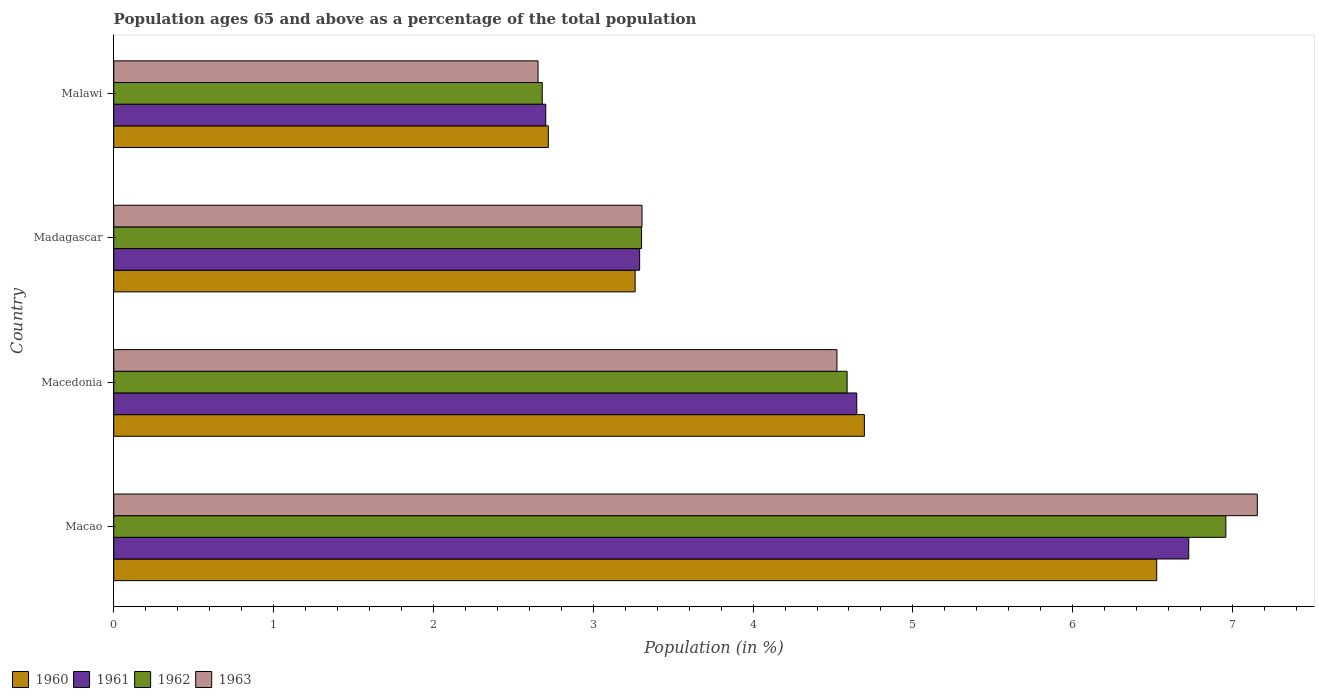How many different coloured bars are there?
Give a very brief answer. 4. How many groups of bars are there?
Your answer should be compact. 4. Are the number of bars on each tick of the Y-axis equal?
Keep it short and to the point. Yes. How many bars are there on the 2nd tick from the bottom?
Ensure brevity in your answer.  4. What is the label of the 2nd group of bars from the top?
Provide a succinct answer. Madagascar. What is the percentage of the population ages 65 and above in 1961 in Madagascar?
Make the answer very short. 3.29. Across all countries, what is the maximum percentage of the population ages 65 and above in 1963?
Provide a succinct answer. 7.15. Across all countries, what is the minimum percentage of the population ages 65 and above in 1963?
Provide a succinct answer. 2.65. In which country was the percentage of the population ages 65 and above in 1962 maximum?
Your response must be concise. Macao. In which country was the percentage of the population ages 65 and above in 1960 minimum?
Keep it short and to the point. Malawi. What is the total percentage of the population ages 65 and above in 1963 in the graph?
Your answer should be very brief. 17.64. What is the difference between the percentage of the population ages 65 and above in 1961 in Macao and that in Madagascar?
Keep it short and to the point. 3.44. What is the difference between the percentage of the population ages 65 and above in 1961 in Malawi and the percentage of the population ages 65 and above in 1960 in Madagascar?
Your response must be concise. -0.56. What is the average percentage of the population ages 65 and above in 1961 per country?
Offer a very short reply. 4.34. What is the difference between the percentage of the population ages 65 and above in 1960 and percentage of the population ages 65 and above in 1963 in Macao?
Provide a short and direct response. -0.63. What is the ratio of the percentage of the population ages 65 and above in 1962 in Madagascar to that in Malawi?
Make the answer very short. 1.23. What is the difference between the highest and the second highest percentage of the population ages 65 and above in 1961?
Give a very brief answer. 2.08. What is the difference between the highest and the lowest percentage of the population ages 65 and above in 1961?
Your answer should be compact. 4.02. Is the sum of the percentage of the population ages 65 and above in 1962 in Macedonia and Malawi greater than the maximum percentage of the population ages 65 and above in 1963 across all countries?
Your answer should be very brief. Yes. Is it the case that in every country, the sum of the percentage of the population ages 65 and above in 1961 and percentage of the population ages 65 and above in 1962 is greater than the sum of percentage of the population ages 65 and above in 1960 and percentage of the population ages 65 and above in 1963?
Provide a short and direct response. No. What does the 1st bar from the top in Macao represents?
Your response must be concise. 1963. Are all the bars in the graph horizontal?
Your answer should be compact. Yes. How many countries are there in the graph?
Give a very brief answer. 4. What is the difference between two consecutive major ticks on the X-axis?
Keep it short and to the point. 1. Are the values on the major ticks of X-axis written in scientific E-notation?
Your answer should be compact. No. Does the graph contain any zero values?
Offer a terse response. No. How many legend labels are there?
Make the answer very short. 4. How are the legend labels stacked?
Provide a succinct answer. Horizontal. What is the title of the graph?
Your answer should be very brief. Population ages 65 and above as a percentage of the total population. What is the label or title of the X-axis?
Give a very brief answer. Population (in %). What is the Population (in %) of 1960 in Macao?
Offer a very short reply. 6.53. What is the Population (in %) in 1961 in Macao?
Your answer should be very brief. 6.73. What is the Population (in %) in 1962 in Macao?
Your answer should be compact. 6.96. What is the Population (in %) of 1963 in Macao?
Your answer should be compact. 7.15. What is the Population (in %) of 1960 in Macedonia?
Your answer should be very brief. 4.7. What is the Population (in %) of 1961 in Macedonia?
Provide a succinct answer. 4.65. What is the Population (in %) in 1962 in Macedonia?
Offer a terse response. 4.59. What is the Population (in %) in 1963 in Macedonia?
Your response must be concise. 4.52. What is the Population (in %) in 1960 in Madagascar?
Provide a succinct answer. 3.26. What is the Population (in %) in 1961 in Madagascar?
Keep it short and to the point. 3.29. What is the Population (in %) in 1962 in Madagascar?
Your answer should be very brief. 3.3. What is the Population (in %) of 1963 in Madagascar?
Provide a short and direct response. 3.31. What is the Population (in %) of 1960 in Malawi?
Keep it short and to the point. 2.72. What is the Population (in %) in 1961 in Malawi?
Offer a terse response. 2.7. What is the Population (in %) in 1962 in Malawi?
Make the answer very short. 2.68. What is the Population (in %) of 1963 in Malawi?
Provide a short and direct response. 2.65. Across all countries, what is the maximum Population (in %) of 1960?
Provide a succinct answer. 6.53. Across all countries, what is the maximum Population (in %) of 1961?
Your answer should be very brief. 6.73. Across all countries, what is the maximum Population (in %) in 1962?
Your answer should be very brief. 6.96. Across all countries, what is the maximum Population (in %) in 1963?
Your response must be concise. 7.15. Across all countries, what is the minimum Population (in %) of 1960?
Give a very brief answer. 2.72. Across all countries, what is the minimum Population (in %) of 1961?
Provide a succinct answer. 2.7. Across all countries, what is the minimum Population (in %) of 1962?
Offer a terse response. 2.68. Across all countries, what is the minimum Population (in %) of 1963?
Offer a very short reply. 2.65. What is the total Population (in %) in 1960 in the graph?
Your response must be concise. 17.2. What is the total Population (in %) in 1961 in the graph?
Keep it short and to the point. 17.37. What is the total Population (in %) of 1962 in the graph?
Offer a terse response. 17.53. What is the total Population (in %) of 1963 in the graph?
Your response must be concise. 17.64. What is the difference between the Population (in %) of 1960 in Macao and that in Macedonia?
Your response must be concise. 1.83. What is the difference between the Population (in %) in 1961 in Macao and that in Macedonia?
Give a very brief answer. 2.08. What is the difference between the Population (in %) of 1962 in Macao and that in Macedonia?
Ensure brevity in your answer.  2.37. What is the difference between the Population (in %) in 1963 in Macao and that in Macedonia?
Your response must be concise. 2.63. What is the difference between the Population (in %) in 1960 in Macao and that in Madagascar?
Provide a succinct answer. 3.26. What is the difference between the Population (in %) of 1961 in Macao and that in Madagascar?
Offer a very short reply. 3.44. What is the difference between the Population (in %) in 1962 in Macao and that in Madagascar?
Offer a terse response. 3.66. What is the difference between the Population (in %) in 1963 in Macao and that in Madagascar?
Offer a very short reply. 3.85. What is the difference between the Population (in %) of 1960 in Macao and that in Malawi?
Your answer should be very brief. 3.81. What is the difference between the Population (in %) of 1961 in Macao and that in Malawi?
Your response must be concise. 4.02. What is the difference between the Population (in %) of 1962 in Macao and that in Malawi?
Offer a terse response. 4.28. What is the difference between the Population (in %) in 1963 in Macao and that in Malawi?
Offer a terse response. 4.5. What is the difference between the Population (in %) of 1960 in Macedonia and that in Madagascar?
Keep it short and to the point. 1.43. What is the difference between the Population (in %) in 1961 in Macedonia and that in Madagascar?
Offer a terse response. 1.36. What is the difference between the Population (in %) in 1962 in Macedonia and that in Madagascar?
Your answer should be very brief. 1.29. What is the difference between the Population (in %) in 1963 in Macedonia and that in Madagascar?
Ensure brevity in your answer.  1.22. What is the difference between the Population (in %) in 1960 in Macedonia and that in Malawi?
Make the answer very short. 1.98. What is the difference between the Population (in %) of 1961 in Macedonia and that in Malawi?
Your answer should be compact. 1.95. What is the difference between the Population (in %) in 1962 in Macedonia and that in Malawi?
Give a very brief answer. 1.91. What is the difference between the Population (in %) of 1963 in Macedonia and that in Malawi?
Your answer should be very brief. 1.87. What is the difference between the Population (in %) in 1960 in Madagascar and that in Malawi?
Make the answer very short. 0.54. What is the difference between the Population (in %) of 1961 in Madagascar and that in Malawi?
Keep it short and to the point. 0.59. What is the difference between the Population (in %) of 1962 in Madagascar and that in Malawi?
Keep it short and to the point. 0.62. What is the difference between the Population (in %) of 1963 in Madagascar and that in Malawi?
Keep it short and to the point. 0.65. What is the difference between the Population (in %) of 1960 in Macao and the Population (in %) of 1961 in Macedonia?
Offer a very short reply. 1.88. What is the difference between the Population (in %) in 1960 in Macao and the Population (in %) in 1962 in Macedonia?
Offer a very short reply. 1.94. What is the difference between the Population (in %) of 1960 in Macao and the Population (in %) of 1963 in Macedonia?
Keep it short and to the point. 2. What is the difference between the Population (in %) of 1961 in Macao and the Population (in %) of 1962 in Macedonia?
Your response must be concise. 2.14. What is the difference between the Population (in %) of 1961 in Macao and the Population (in %) of 1963 in Macedonia?
Offer a very short reply. 2.2. What is the difference between the Population (in %) in 1962 in Macao and the Population (in %) in 1963 in Macedonia?
Ensure brevity in your answer.  2.43. What is the difference between the Population (in %) in 1960 in Macao and the Population (in %) in 1961 in Madagascar?
Your answer should be very brief. 3.23. What is the difference between the Population (in %) of 1960 in Macao and the Population (in %) of 1962 in Madagascar?
Give a very brief answer. 3.22. What is the difference between the Population (in %) of 1960 in Macao and the Population (in %) of 1963 in Madagascar?
Your answer should be compact. 3.22. What is the difference between the Population (in %) of 1961 in Macao and the Population (in %) of 1962 in Madagascar?
Offer a very short reply. 3.42. What is the difference between the Population (in %) of 1961 in Macao and the Population (in %) of 1963 in Madagascar?
Your answer should be compact. 3.42. What is the difference between the Population (in %) of 1962 in Macao and the Population (in %) of 1963 in Madagascar?
Keep it short and to the point. 3.65. What is the difference between the Population (in %) of 1960 in Macao and the Population (in %) of 1961 in Malawi?
Offer a very short reply. 3.82. What is the difference between the Population (in %) in 1960 in Macao and the Population (in %) in 1962 in Malawi?
Keep it short and to the point. 3.84. What is the difference between the Population (in %) in 1960 in Macao and the Population (in %) in 1963 in Malawi?
Make the answer very short. 3.87. What is the difference between the Population (in %) of 1961 in Macao and the Population (in %) of 1962 in Malawi?
Provide a succinct answer. 4.04. What is the difference between the Population (in %) of 1961 in Macao and the Population (in %) of 1963 in Malawi?
Offer a very short reply. 4.07. What is the difference between the Population (in %) in 1962 in Macao and the Population (in %) in 1963 in Malawi?
Your answer should be compact. 4.3. What is the difference between the Population (in %) of 1960 in Macedonia and the Population (in %) of 1961 in Madagascar?
Provide a short and direct response. 1.41. What is the difference between the Population (in %) of 1960 in Macedonia and the Population (in %) of 1962 in Madagascar?
Offer a very short reply. 1.39. What is the difference between the Population (in %) in 1960 in Macedonia and the Population (in %) in 1963 in Madagascar?
Give a very brief answer. 1.39. What is the difference between the Population (in %) in 1961 in Macedonia and the Population (in %) in 1962 in Madagascar?
Offer a terse response. 1.35. What is the difference between the Population (in %) of 1961 in Macedonia and the Population (in %) of 1963 in Madagascar?
Ensure brevity in your answer.  1.34. What is the difference between the Population (in %) in 1962 in Macedonia and the Population (in %) in 1963 in Madagascar?
Give a very brief answer. 1.28. What is the difference between the Population (in %) of 1960 in Macedonia and the Population (in %) of 1961 in Malawi?
Ensure brevity in your answer.  1.99. What is the difference between the Population (in %) of 1960 in Macedonia and the Population (in %) of 1962 in Malawi?
Keep it short and to the point. 2.02. What is the difference between the Population (in %) of 1960 in Macedonia and the Population (in %) of 1963 in Malawi?
Your response must be concise. 2.04. What is the difference between the Population (in %) of 1961 in Macedonia and the Population (in %) of 1962 in Malawi?
Offer a terse response. 1.97. What is the difference between the Population (in %) in 1961 in Macedonia and the Population (in %) in 1963 in Malawi?
Your answer should be very brief. 1.99. What is the difference between the Population (in %) in 1962 in Macedonia and the Population (in %) in 1963 in Malawi?
Your response must be concise. 1.93. What is the difference between the Population (in %) of 1960 in Madagascar and the Population (in %) of 1961 in Malawi?
Offer a very short reply. 0.56. What is the difference between the Population (in %) in 1960 in Madagascar and the Population (in %) in 1962 in Malawi?
Give a very brief answer. 0.58. What is the difference between the Population (in %) in 1960 in Madagascar and the Population (in %) in 1963 in Malawi?
Offer a terse response. 0.61. What is the difference between the Population (in %) of 1961 in Madagascar and the Population (in %) of 1962 in Malawi?
Provide a succinct answer. 0.61. What is the difference between the Population (in %) of 1961 in Madagascar and the Population (in %) of 1963 in Malawi?
Keep it short and to the point. 0.64. What is the difference between the Population (in %) of 1962 in Madagascar and the Population (in %) of 1963 in Malawi?
Keep it short and to the point. 0.65. What is the average Population (in %) of 1960 per country?
Provide a succinct answer. 4.3. What is the average Population (in %) of 1961 per country?
Offer a very short reply. 4.34. What is the average Population (in %) of 1962 per country?
Ensure brevity in your answer.  4.38. What is the average Population (in %) of 1963 per country?
Provide a succinct answer. 4.41. What is the difference between the Population (in %) in 1960 and Population (in %) in 1961 in Macao?
Your answer should be compact. -0.2. What is the difference between the Population (in %) of 1960 and Population (in %) of 1962 in Macao?
Ensure brevity in your answer.  -0.43. What is the difference between the Population (in %) of 1960 and Population (in %) of 1963 in Macao?
Keep it short and to the point. -0.63. What is the difference between the Population (in %) of 1961 and Population (in %) of 1962 in Macao?
Your answer should be very brief. -0.23. What is the difference between the Population (in %) in 1961 and Population (in %) in 1963 in Macao?
Provide a succinct answer. -0.43. What is the difference between the Population (in %) in 1962 and Population (in %) in 1963 in Macao?
Ensure brevity in your answer.  -0.2. What is the difference between the Population (in %) of 1960 and Population (in %) of 1961 in Macedonia?
Keep it short and to the point. 0.05. What is the difference between the Population (in %) in 1960 and Population (in %) in 1962 in Macedonia?
Keep it short and to the point. 0.11. What is the difference between the Population (in %) of 1960 and Population (in %) of 1963 in Macedonia?
Make the answer very short. 0.17. What is the difference between the Population (in %) in 1961 and Population (in %) in 1962 in Macedonia?
Ensure brevity in your answer.  0.06. What is the difference between the Population (in %) of 1961 and Population (in %) of 1963 in Macedonia?
Ensure brevity in your answer.  0.12. What is the difference between the Population (in %) in 1962 and Population (in %) in 1963 in Macedonia?
Offer a very short reply. 0.06. What is the difference between the Population (in %) of 1960 and Population (in %) of 1961 in Madagascar?
Your answer should be compact. -0.03. What is the difference between the Population (in %) of 1960 and Population (in %) of 1962 in Madagascar?
Provide a succinct answer. -0.04. What is the difference between the Population (in %) in 1960 and Population (in %) in 1963 in Madagascar?
Your answer should be compact. -0.04. What is the difference between the Population (in %) in 1961 and Population (in %) in 1962 in Madagascar?
Offer a terse response. -0.01. What is the difference between the Population (in %) in 1961 and Population (in %) in 1963 in Madagascar?
Provide a short and direct response. -0.01. What is the difference between the Population (in %) in 1962 and Population (in %) in 1963 in Madagascar?
Make the answer very short. -0. What is the difference between the Population (in %) of 1960 and Population (in %) of 1961 in Malawi?
Ensure brevity in your answer.  0.02. What is the difference between the Population (in %) in 1960 and Population (in %) in 1962 in Malawi?
Give a very brief answer. 0.04. What is the difference between the Population (in %) in 1960 and Population (in %) in 1963 in Malawi?
Provide a short and direct response. 0.06. What is the difference between the Population (in %) in 1961 and Population (in %) in 1962 in Malawi?
Offer a terse response. 0.02. What is the difference between the Population (in %) of 1961 and Population (in %) of 1963 in Malawi?
Keep it short and to the point. 0.05. What is the difference between the Population (in %) in 1962 and Population (in %) in 1963 in Malawi?
Provide a succinct answer. 0.03. What is the ratio of the Population (in %) of 1960 in Macao to that in Macedonia?
Keep it short and to the point. 1.39. What is the ratio of the Population (in %) of 1961 in Macao to that in Macedonia?
Keep it short and to the point. 1.45. What is the ratio of the Population (in %) in 1962 in Macao to that in Macedonia?
Offer a terse response. 1.52. What is the ratio of the Population (in %) in 1963 in Macao to that in Macedonia?
Keep it short and to the point. 1.58. What is the ratio of the Population (in %) of 1960 in Macao to that in Madagascar?
Offer a terse response. 2. What is the ratio of the Population (in %) of 1961 in Macao to that in Madagascar?
Your response must be concise. 2.04. What is the ratio of the Population (in %) in 1962 in Macao to that in Madagascar?
Ensure brevity in your answer.  2.11. What is the ratio of the Population (in %) of 1963 in Macao to that in Madagascar?
Offer a terse response. 2.16. What is the ratio of the Population (in %) in 1960 in Macao to that in Malawi?
Provide a succinct answer. 2.4. What is the ratio of the Population (in %) of 1961 in Macao to that in Malawi?
Make the answer very short. 2.49. What is the ratio of the Population (in %) in 1962 in Macao to that in Malawi?
Provide a succinct answer. 2.6. What is the ratio of the Population (in %) of 1963 in Macao to that in Malawi?
Make the answer very short. 2.7. What is the ratio of the Population (in %) of 1960 in Macedonia to that in Madagascar?
Your response must be concise. 1.44. What is the ratio of the Population (in %) of 1961 in Macedonia to that in Madagascar?
Offer a terse response. 1.41. What is the ratio of the Population (in %) of 1962 in Macedonia to that in Madagascar?
Make the answer very short. 1.39. What is the ratio of the Population (in %) in 1963 in Macedonia to that in Madagascar?
Your answer should be compact. 1.37. What is the ratio of the Population (in %) of 1960 in Macedonia to that in Malawi?
Your answer should be very brief. 1.73. What is the ratio of the Population (in %) in 1961 in Macedonia to that in Malawi?
Provide a succinct answer. 1.72. What is the ratio of the Population (in %) of 1962 in Macedonia to that in Malawi?
Keep it short and to the point. 1.71. What is the ratio of the Population (in %) of 1963 in Macedonia to that in Malawi?
Make the answer very short. 1.7. What is the ratio of the Population (in %) in 1960 in Madagascar to that in Malawi?
Your answer should be compact. 1.2. What is the ratio of the Population (in %) of 1961 in Madagascar to that in Malawi?
Ensure brevity in your answer.  1.22. What is the ratio of the Population (in %) of 1962 in Madagascar to that in Malawi?
Provide a short and direct response. 1.23. What is the ratio of the Population (in %) in 1963 in Madagascar to that in Malawi?
Provide a short and direct response. 1.25. What is the difference between the highest and the second highest Population (in %) in 1960?
Your response must be concise. 1.83. What is the difference between the highest and the second highest Population (in %) in 1961?
Provide a short and direct response. 2.08. What is the difference between the highest and the second highest Population (in %) in 1962?
Provide a short and direct response. 2.37. What is the difference between the highest and the second highest Population (in %) in 1963?
Give a very brief answer. 2.63. What is the difference between the highest and the lowest Population (in %) of 1960?
Provide a short and direct response. 3.81. What is the difference between the highest and the lowest Population (in %) of 1961?
Offer a terse response. 4.02. What is the difference between the highest and the lowest Population (in %) in 1962?
Your answer should be very brief. 4.28. What is the difference between the highest and the lowest Population (in %) of 1963?
Offer a terse response. 4.5. 